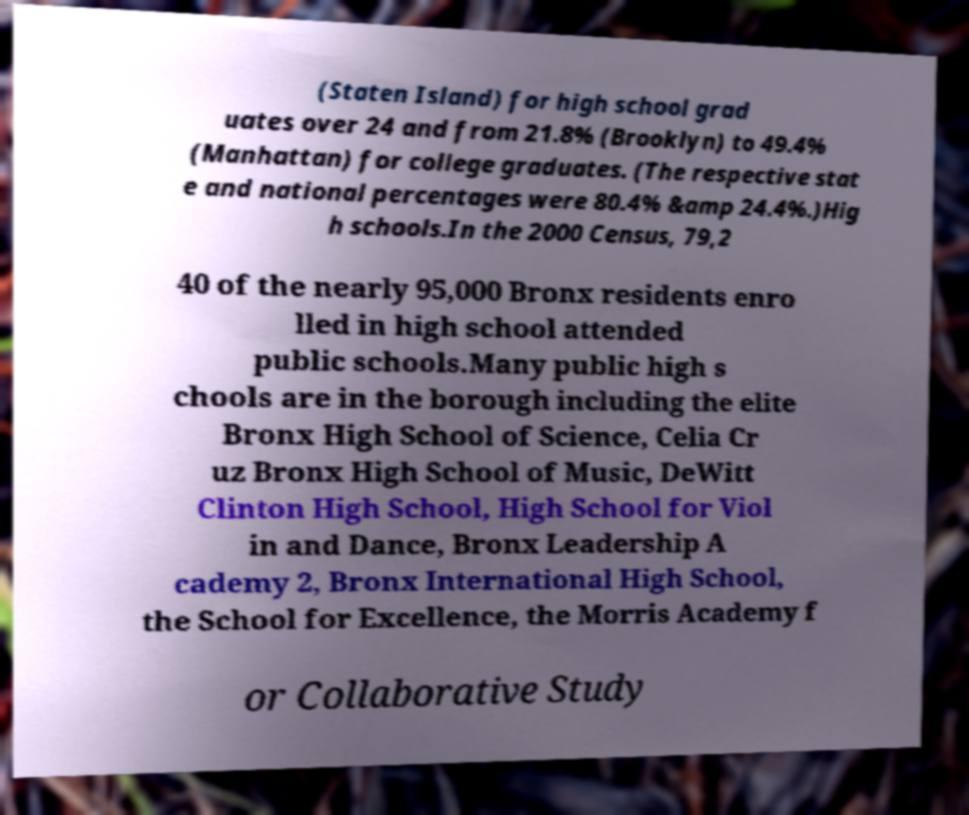Can you read and provide the text displayed in the image?This photo seems to have some interesting text. Can you extract and type it out for me? (Staten Island) for high school grad uates over 24 and from 21.8% (Brooklyn) to 49.4% (Manhattan) for college graduates. (The respective stat e and national percentages were 80.4% &amp 24.4%.)Hig h schools.In the 2000 Census, 79,2 40 of the nearly 95,000 Bronx residents enro lled in high school attended public schools.Many public high s chools are in the borough including the elite Bronx High School of Science, Celia Cr uz Bronx High School of Music, DeWitt Clinton High School, High School for Viol in and Dance, Bronx Leadership A cademy 2, Bronx International High School, the School for Excellence, the Morris Academy f or Collaborative Study 